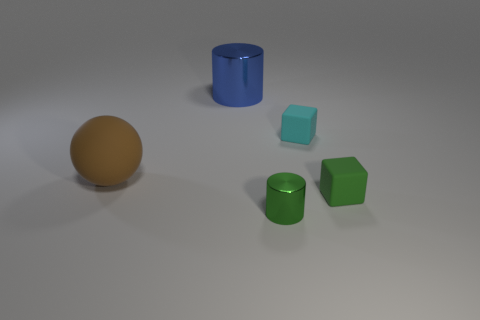Add 5 tiny cyan metallic balls. How many objects exist? 10 Subtract all balls. How many objects are left? 4 Add 5 small red rubber blocks. How many small red rubber blocks exist? 5 Subtract 0 red cubes. How many objects are left? 5 Subtract all large green balls. Subtract all cyan rubber objects. How many objects are left? 4 Add 2 brown rubber spheres. How many brown rubber spheres are left? 3 